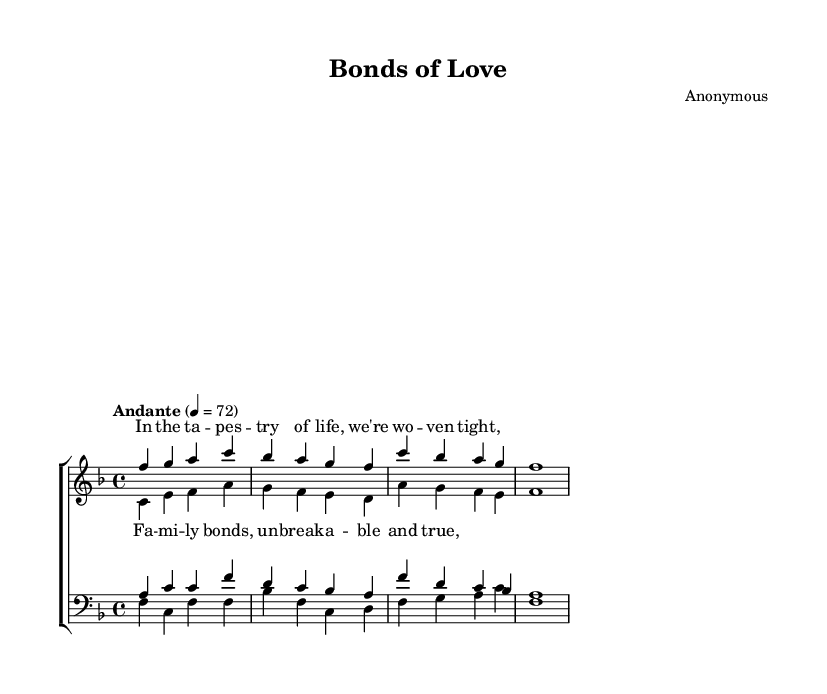What is the key signature of this music? The key signature indicates the notes that are sharp or flat throughout the piece. Looking at the beginning of the staff, we see one flat, which indicates the key of F major.
Answer: F major What is the time signature of this music? The time signature is found at the beginning of the score, indicating how many beats are in each measure. Here, the 4 over 4 indicates four beats per measure, which shows that it's in common time.
Answer: 4/4 What is the tempo marking given for this piece? The tempo marking is typically indicated above the staff at the beginning. In this sheet music, it shows "Andante" with a metronome marking of 72 beats per minute, suggesting a moderate pace.
Answer: Andante How many vocal parts are there in the score? By examining the score layout, we can see that there are two main sections: one for women (soprano and alto) and one for men (tenor and bass), making a total of four vocal parts.
Answer: Four What is the theme expressed in the lyrics? The lyrics discuss family ties and unity, as seen in the phrases of the song. The chorus emphasizes "Family bonds, unbreakable and true," highlighting the strength of these bonds in the context of a family.
Answer: Family bonds Which vocal part has the highest pitch range? The soprano part is typically performed by higher voices, and looking at the pitch notation, we see that it starts on F' and has notes that reach up to C', which situates it in the higher range compared to the other parts.
Answer: Soprano What emotional quality can be inferred from the dynamics of this piece? While specific dynamics are not indicated in the provided excerpts, the overall style and tempo of "Andante" often convey a calm and reflective emotional quality, suited to the theme of familial strength.
Answer: Calm 